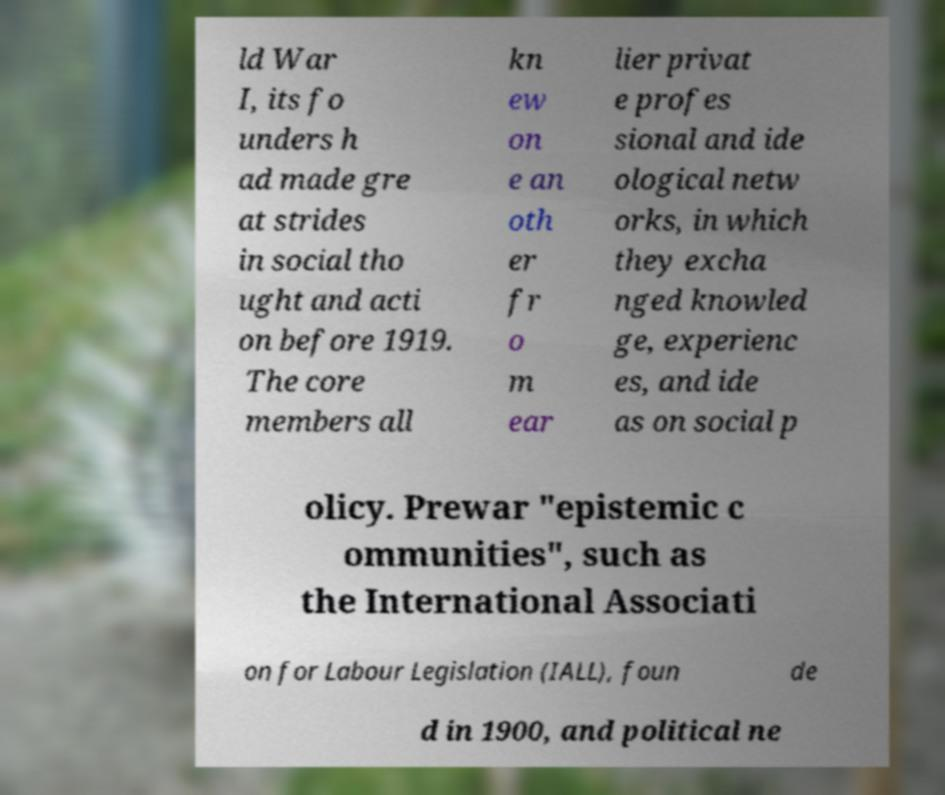Could you assist in decoding the text presented in this image and type it out clearly? ld War I, its fo unders h ad made gre at strides in social tho ught and acti on before 1919. The core members all kn ew on e an oth er fr o m ear lier privat e profes sional and ide ological netw orks, in which they excha nged knowled ge, experienc es, and ide as on social p olicy. Prewar "epistemic c ommunities", such as the International Associati on for Labour Legislation (IALL), foun de d in 1900, and political ne 